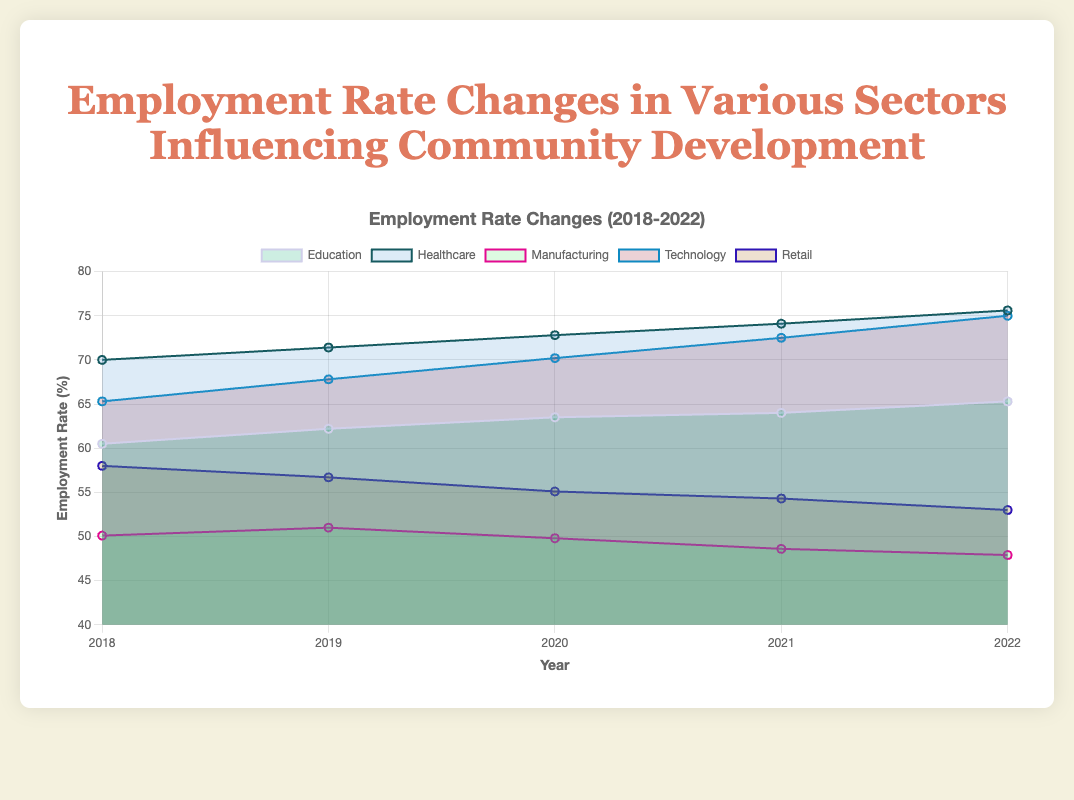What is the general trend for the employment rate in the Healthcare sector from 2018 to 2022? The employment rate in the Healthcare sector shows a consistent upward trend each year. Starting at 70.0% in 2018, it increases to 71.4% in 2019, reaches 72.8% in 2020, 74.1% in 2021, and finally, 75.6% in 2022.
Answer: Increasing Which sector had the highest employment rate in 2018? By examining the plotted data points for each sector in 2018, the highest employment rate is seen in the Healthcare sector at 70.0%.
Answer: Healthcare How did the employment rate in the Retail sector change from 2018 to 2022? The employment rate in the Retail sector decreased over these years. It started at 58.0% in 2018 and gradually dropped to 53.0% by 2022.
Answer: Decreased What is the difference in the employment rate between Technology and Manufacturing in 2022? In 2022, the employment rate in the Technology sector was 75.0%, while in the Manufacturing sector it was 47.9%. The difference is calculated as 75.0% - 47.9% = 27.1%.
Answer: 27.1% Among the sectors listed, which one shows a decline in employment rate between 2018 and 2022? By comparing the trends, the Manufacturing and Retail sectors show a decline in employment rates over this period. Manufacturing went from 50.1% to 47.9%, and Retail went from 58.0% to 53.0%.
Answer: Manufacturing and Retail Which sector saw the largest growth in employment rate from 2018 to 2022? By comparing the growth from 2018 to 2022 for each sector: 
- Education: 65.3 - 60.5 = 4.8
- Healthcare: 75.6 - 70.0 = 5.6
- Manufacturing: 47.9 - 50.1 = -2.2
- Technology: 75.0 - 65.3 = 9.7
- Retail: 53.0 - 58.0 = - 5.0
The Technology sector saw the largest growth, increasing by 9.7%.
Answer: Technology If we average the employment rates for the Education sector over the five years, what would it be? The employment rates for the Education sector from 2018 to 2022 are 60.5, 62.2, 63.5, 64.0, and 65.3. The average is calculated as (60.5 + 62.2 + 63.5 + 64.0 + 65.3)/5 = 63.1%.
Answer: 63.1% Between 2018 and 2022, which year had the highest overall employment rate across all sectors? By examining the plotted data, the highest employment rates for each year can be noted. For an overall assessment, some interpretation is required, but typically Healthcare (75.6% in 2022) and Technology (75.0% in 2022) suggest that 2022 had particularly high rates.
Answer: 2022 What is the employment rate trend in the Education sector? Upon reviewing the plotted data, the Education sector shows a consistently upward trend, with employment rates increasing from 60.5% in 2018 to 65.3% in 2022.
Answer: Increasing 